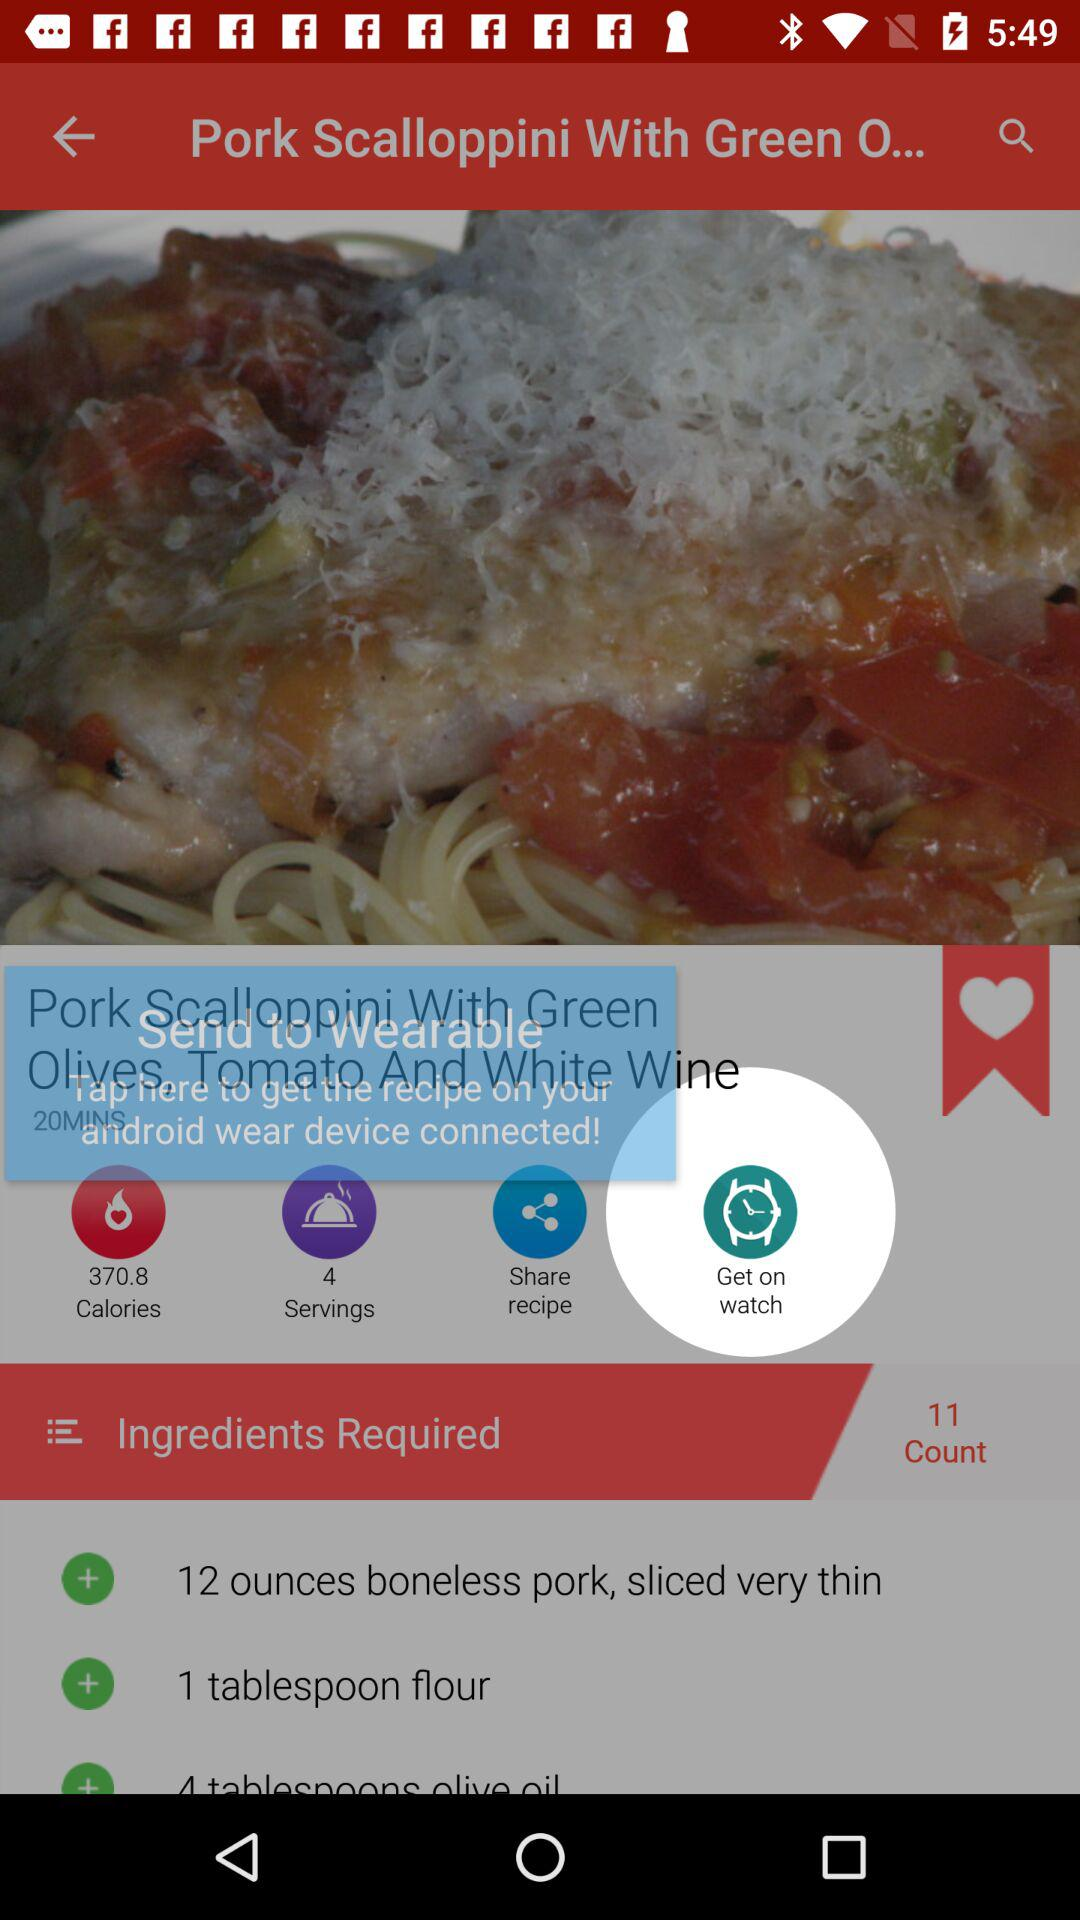How many ingredients are in the recipe?
Answer the question using a single word or phrase. 11 